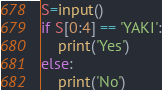Convert code to text. <code><loc_0><loc_0><loc_500><loc_500><_Python_>S=input()
if S[0:4] == 'YAKI':
    print('Yes')
else:
    print('No')</code> 